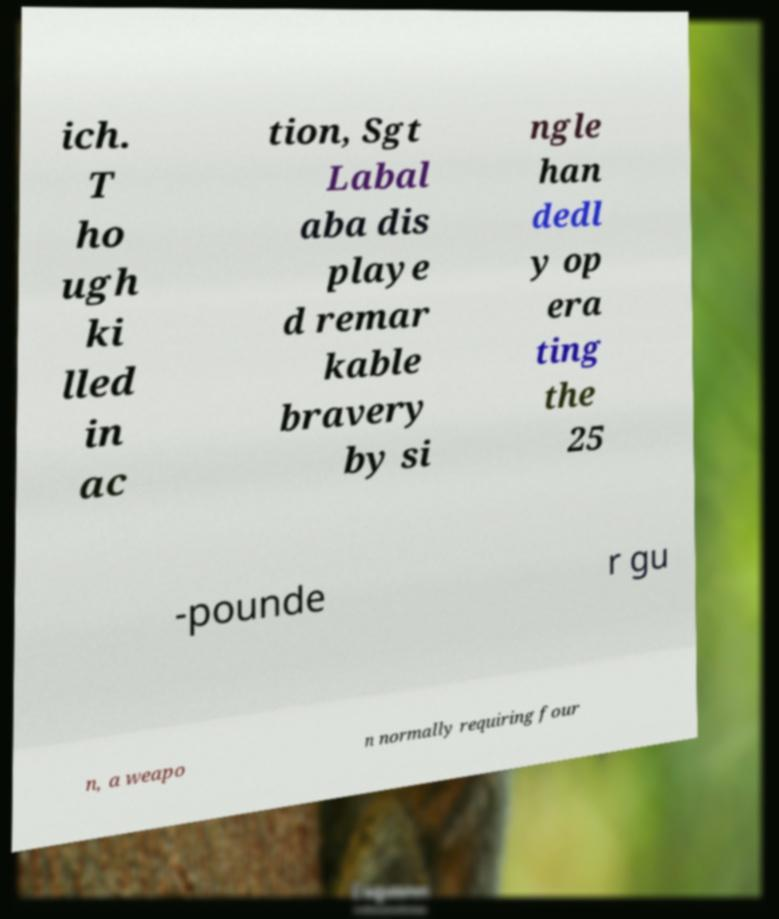Please read and relay the text visible in this image. What does it say? ich. T ho ugh ki lled in ac tion, Sgt Labal aba dis playe d remar kable bravery by si ngle han dedl y op era ting the 25 -pounde r gu n, a weapo n normally requiring four 